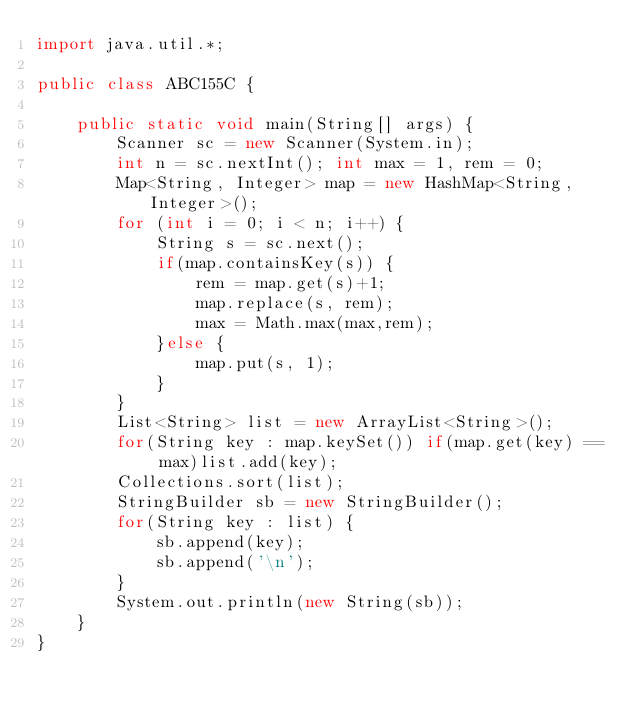<code> <loc_0><loc_0><loc_500><loc_500><_Java_>import java.util.*;

public class ABC155C {

	public static void main(String[] args) {
		Scanner sc = new Scanner(System.in);
		int n = sc.nextInt(); int max = 1, rem = 0;
		Map<String, Integer> map = new HashMap<String, Integer>();
		for (int i = 0; i < n; i++) {
			String s = sc.next();
			if(map.containsKey(s)) {
				rem = map.get(s)+1;
				map.replace(s, rem);
				max = Math.max(max,rem);
			}else {
				map.put(s, 1);
			}
		}
		List<String> list = new ArrayList<String>();
		for(String key : map.keySet()) if(map.get(key) == max)list.add(key);
		Collections.sort(list);
		StringBuilder sb = new StringBuilder();
		for(String key : list) {
			sb.append(key);
			sb.append('\n');
		}
		System.out.println(new String(sb));
	}
}</code> 